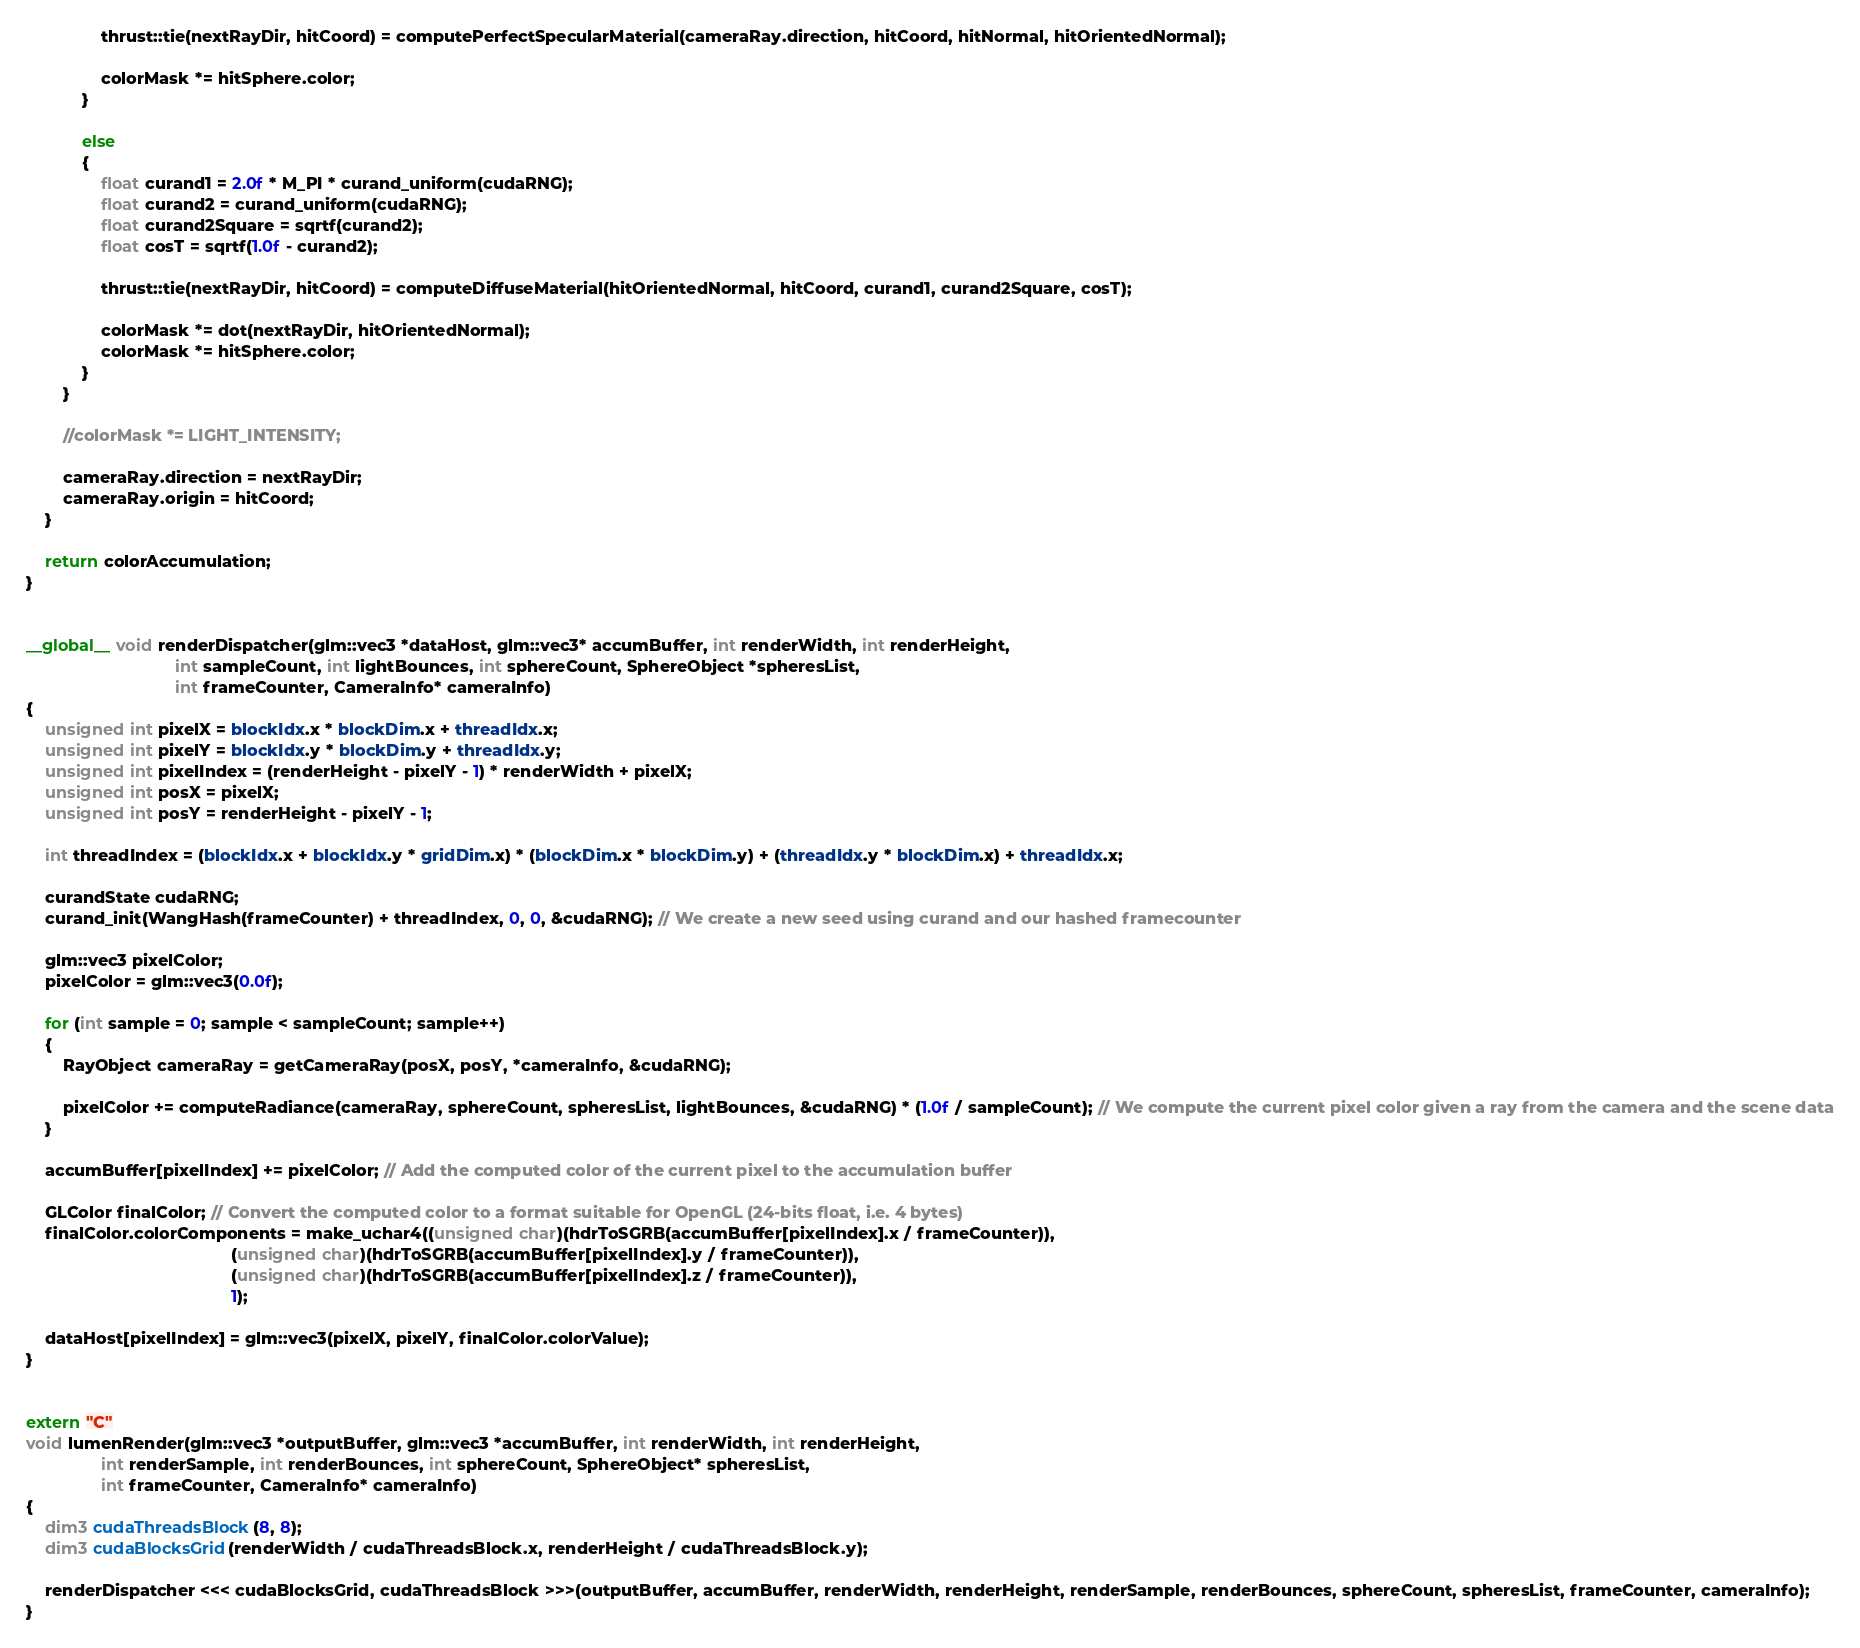<code> <loc_0><loc_0><loc_500><loc_500><_Cuda_>                thrust::tie(nextRayDir, hitCoord) = computePerfectSpecularMaterial(cameraRay.direction, hitCoord, hitNormal, hitOrientedNormal);

                colorMask *= hitSphere.color;
            }

            else
            {
                float curand1 = 2.0f * M_PI * curand_uniform(cudaRNG);
                float curand2 = curand_uniform(cudaRNG);
                float curand2Square = sqrtf(curand2);
                float cosT = sqrtf(1.0f - curand2);

                thrust::tie(nextRayDir, hitCoord) = computeDiffuseMaterial(hitOrientedNormal, hitCoord, curand1, curand2Square, cosT);

                colorMask *= dot(nextRayDir, hitOrientedNormal);
                colorMask *= hitSphere.color;
            }
        }

        //colorMask *= LIGHT_INTENSITY;

        cameraRay.direction = nextRayDir;
        cameraRay.origin = hitCoord;
    }

    return colorAccumulation;
}


__global__ void renderDispatcher(glm::vec3 *dataHost, glm::vec3* accumBuffer, int renderWidth, int renderHeight,
                                int sampleCount, int lightBounces, int sphereCount, SphereObject *spheresList,
                                int frameCounter, CameraInfo* cameraInfo)
{
    unsigned int pixelX = blockIdx.x * blockDim.x + threadIdx.x;
    unsigned int pixelY = blockIdx.y * blockDim.y + threadIdx.y;
    unsigned int pixelIndex = (renderHeight - pixelY - 1) * renderWidth + pixelX;
    unsigned int posX = pixelX;
    unsigned int posY = renderHeight - pixelY - 1;

    int threadIndex = (blockIdx.x + blockIdx.y * gridDim.x) * (blockDim.x * blockDim.y) + (threadIdx.y * blockDim.x) + threadIdx.x;

    curandState cudaRNG;
    curand_init(WangHash(frameCounter) + threadIndex, 0, 0, &cudaRNG); // We create a new seed using curand and our hashed framecounter

    glm::vec3 pixelColor;
    pixelColor = glm::vec3(0.0f);

    for (int sample = 0; sample < sampleCount; sample++)
    {
        RayObject cameraRay = getCameraRay(posX, posY, *cameraInfo, &cudaRNG);

        pixelColor += computeRadiance(cameraRay, sphereCount, spheresList, lightBounces, &cudaRNG) * (1.0f / sampleCount); // We compute the current pixel color given a ray from the camera and the scene data
    }

    accumBuffer[pixelIndex] += pixelColor; // Add the computed color of the current pixel to the accumulation buffer

    GLColor finalColor; // Convert the computed color to a format suitable for OpenGL (24-bits float, i.e. 4 bytes)
    finalColor.colorComponents = make_uchar4((unsigned char)(hdrToSGRB(accumBuffer[pixelIndex].x / frameCounter)),
                                            (unsigned char)(hdrToSGRB(accumBuffer[pixelIndex].y / frameCounter)),
                                            (unsigned char)(hdrToSGRB(accumBuffer[pixelIndex].z / frameCounter)),
                                            1);

    dataHost[pixelIndex] = glm::vec3(pixelX, pixelY, finalColor.colorValue);
}


extern "C"
void lumenRender(glm::vec3 *outputBuffer, glm::vec3 *accumBuffer, int renderWidth, int renderHeight,
                int renderSample, int renderBounces, int sphereCount, SphereObject* spheresList,
                int frameCounter, CameraInfo* cameraInfo)
{
    dim3 cudaThreadsBlock(8, 8);
    dim3 cudaBlocksGrid(renderWidth / cudaThreadsBlock.x, renderHeight / cudaThreadsBlock.y);

    renderDispatcher <<< cudaBlocksGrid, cudaThreadsBlock >>>(outputBuffer, accumBuffer, renderWidth, renderHeight, renderSample, renderBounces, sphereCount, spheresList, frameCounter, cameraInfo);
}
</code> 